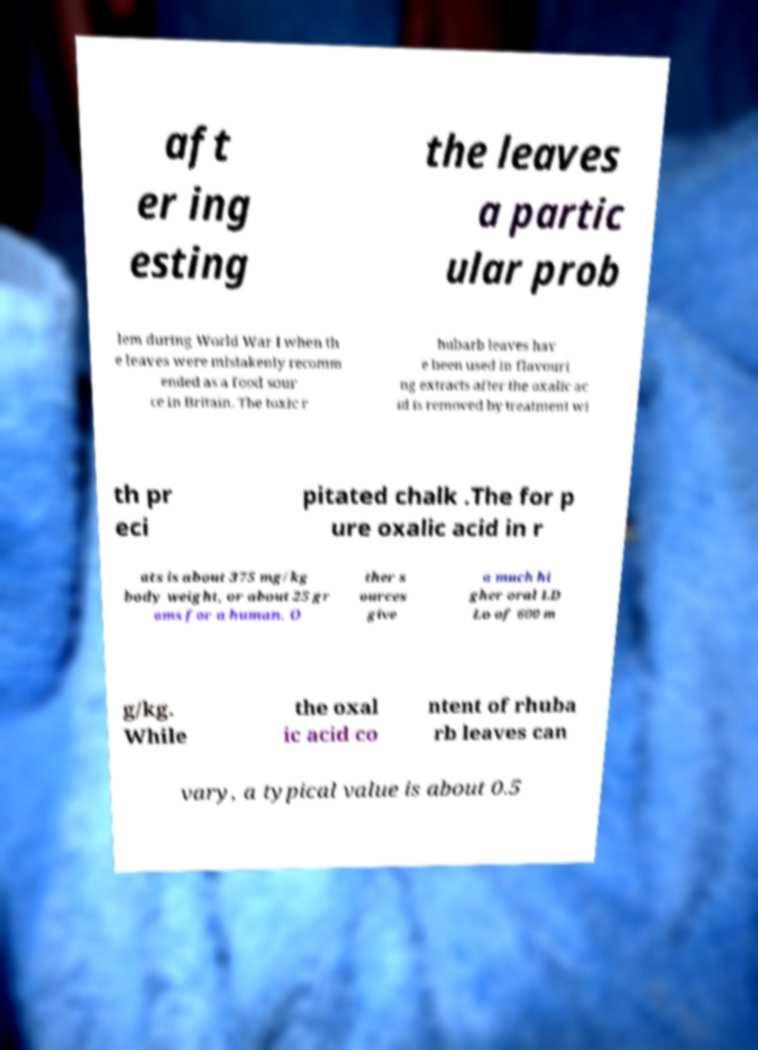Can you read and provide the text displayed in the image?This photo seems to have some interesting text. Can you extract and type it out for me? aft er ing esting the leaves a partic ular prob lem during World War I when th e leaves were mistakenly recomm ended as a food sour ce in Britain. The toxic r hubarb leaves hav e been used in flavouri ng extracts after the oxalic ac id is removed by treatment wi th pr eci pitated chalk .The for p ure oxalic acid in r ats is about 375 mg/kg body weight, or about 25 gr ams for a human. O ther s ources give a much hi gher oral LD Lo of 600 m g/kg. While the oxal ic acid co ntent of rhuba rb leaves can vary, a typical value is about 0.5 